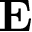<formula> <loc_0><loc_0><loc_500><loc_500>E</formula> 